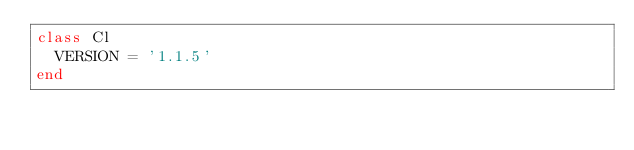Convert code to text. <code><loc_0><loc_0><loc_500><loc_500><_Ruby_>class Cl
  VERSION = '1.1.5'
end
</code> 